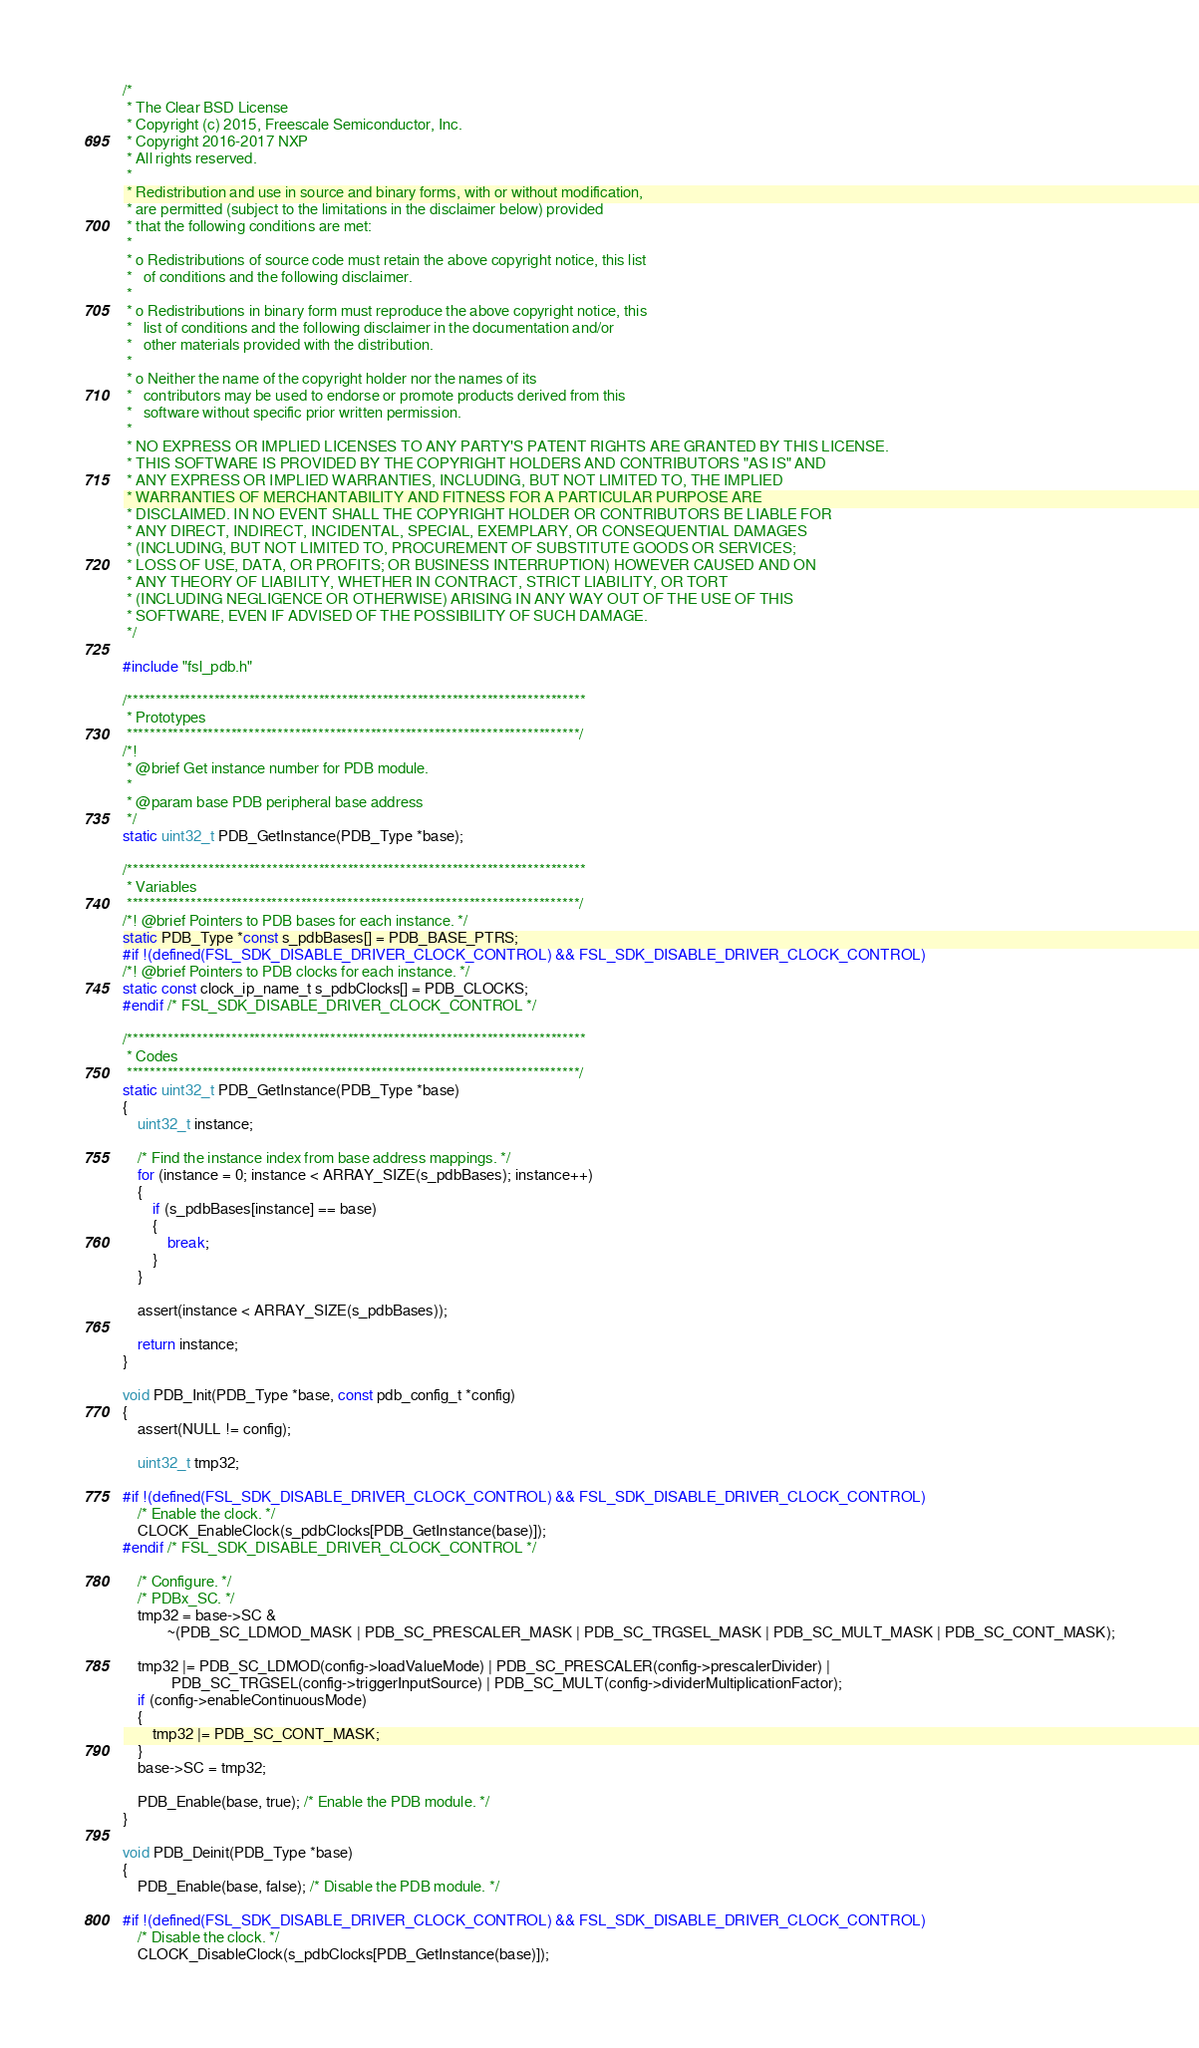<code> <loc_0><loc_0><loc_500><loc_500><_C_>/*
 * The Clear BSD License
 * Copyright (c) 2015, Freescale Semiconductor, Inc.
 * Copyright 2016-2017 NXP
 * All rights reserved.
 *
 * Redistribution and use in source and binary forms, with or without modification,
 * are permitted (subject to the limitations in the disclaimer below) provided
 * that the following conditions are met:
 *
 * o Redistributions of source code must retain the above copyright notice, this list
 *   of conditions and the following disclaimer.
 *
 * o Redistributions in binary form must reproduce the above copyright notice, this
 *   list of conditions and the following disclaimer in the documentation and/or
 *   other materials provided with the distribution.
 *
 * o Neither the name of the copyright holder nor the names of its
 *   contributors may be used to endorse or promote products derived from this
 *   software without specific prior written permission.
 *
 * NO EXPRESS OR IMPLIED LICENSES TO ANY PARTY'S PATENT RIGHTS ARE GRANTED BY THIS LICENSE.
 * THIS SOFTWARE IS PROVIDED BY THE COPYRIGHT HOLDERS AND CONTRIBUTORS "AS IS" AND
 * ANY EXPRESS OR IMPLIED WARRANTIES, INCLUDING, BUT NOT LIMITED TO, THE IMPLIED
 * WARRANTIES OF MERCHANTABILITY AND FITNESS FOR A PARTICULAR PURPOSE ARE
 * DISCLAIMED. IN NO EVENT SHALL THE COPYRIGHT HOLDER OR CONTRIBUTORS BE LIABLE FOR
 * ANY DIRECT, INDIRECT, INCIDENTAL, SPECIAL, EXEMPLARY, OR CONSEQUENTIAL DAMAGES
 * (INCLUDING, BUT NOT LIMITED TO, PROCUREMENT OF SUBSTITUTE GOODS OR SERVICES;
 * LOSS OF USE, DATA, OR PROFITS; OR BUSINESS INTERRUPTION) HOWEVER CAUSED AND ON
 * ANY THEORY OF LIABILITY, WHETHER IN CONTRACT, STRICT LIABILITY, OR TORT
 * (INCLUDING NEGLIGENCE OR OTHERWISE) ARISING IN ANY WAY OUT OF THE USE OF THIS
 * SOFTWARE, EVEN IF ADVISED OF THE POSSIBILITY OF SUCH DAMAGE.
 */

#include "fsl_pdb.h"

/*******************************************************************************
 * Prototypes
 ******************************************************************************/
/*!
 * @brief Get instance number for PDB module.
 *
 * @param base PDB peripheral base address
 */
static uint32_t PDB_GetInstance(PDB_Type *base);

/*******************************************************************************
 * Variables
 ******************************************************************************/
/*! @brief Pointers to PDB bases for each instance. */
static PDB_Type *const s_pdbBases[] = PDB_BASE_PTRS;
#if !(defined(FSL_SDK_DISABLE_DRIVER_CLOCK_CONTROL) && FSL_SDK_DISABLE_DRIVER_CLOCK_CONTROL)
/*! @brief Pointers to PDB clocks for each instance. */
static const clock_ip_name_t s_pdbClocks[] = PDB_CLOCKS;
#endif /* FSL_SDK_DISABLE_DRIVER_CLOCK_CONTROL */

/*******************************************************************************
 * Codes
 ******************************************************************************/
static uint32_t PDB_GetInstance(PDB_Type *base)
{
    uint32_t instance;

    /* Find the instance index from base address mappings. */
    for (instance = 0; instance < ARRAY_SIZE(s_pdbBases); instance++)
    {
        if (s_pdbBases[instance] == base)
        {
            break;
        }
    }

    assert(instance < ARRAY_SIZE(s_pdbBases));

    return instance;
}

void PDB_Init(PDB_Type *base, const pdb_config_t *config)
{
    assert(NULL != config);

    uint32_t tmp32;

#if !(defined(FSL_SDK_DISABLE_DRIVER_CLOCK_CONTROL) && FSL_SDK_DISABLE_DRIVER_CLOCK_CONTROL)
    /* Enable the clock. */
    CLOCK_EnableClock(s_pdbClocks[PDB_GetInstance(base)]);
#endif /* FSL_SDK_DISABLE_DRIVER_CLOCK_CONTROL */

    /* Configure. */
    /* PDBx_SC. */
    tmp32 = base->SC &
            ~(PDB_SC_LDMOD_MASK | PDB_SC_PRESCALER_MASK | PDB_SC_TRGSEL_MASK | PDB_SC_MULT_MASK | PDB_SC_CONT_MASK);

    tmp32 |= PDB_SC_LDMOD(config->loadValueMode) | PDB_SC_PRESCALER(config->prescalerDivider) |
             PDB_SC_TRGSEL(config->triggerInputSource) | PDB_SC_MULT(config->dividerMultiplicationFactor);
    if (config->enableContinuousMode)
    {
        tmp32 |= PDB_SC_CONT_MASK;
    }
    base->SC = tmp32;

    PDB_Enable(base, true); /* Enable the PDB module. */
}

void PDB_Deinit(PDB_Type *base)
{
    PDB_Enable(base, false); /* Disable the PDB module. */

#if !(defined(FSL_SDK_DISABLE_DRIVER_CLOCK_CONTROL) && FSL_SDK_DISABLE_DRIVER_CLOCK_CONTROL)
    /* Disable the clock. */
    CLOCK_DisableClock(s_pdbClocks[PDB_GetInstance(base)]);</code> 